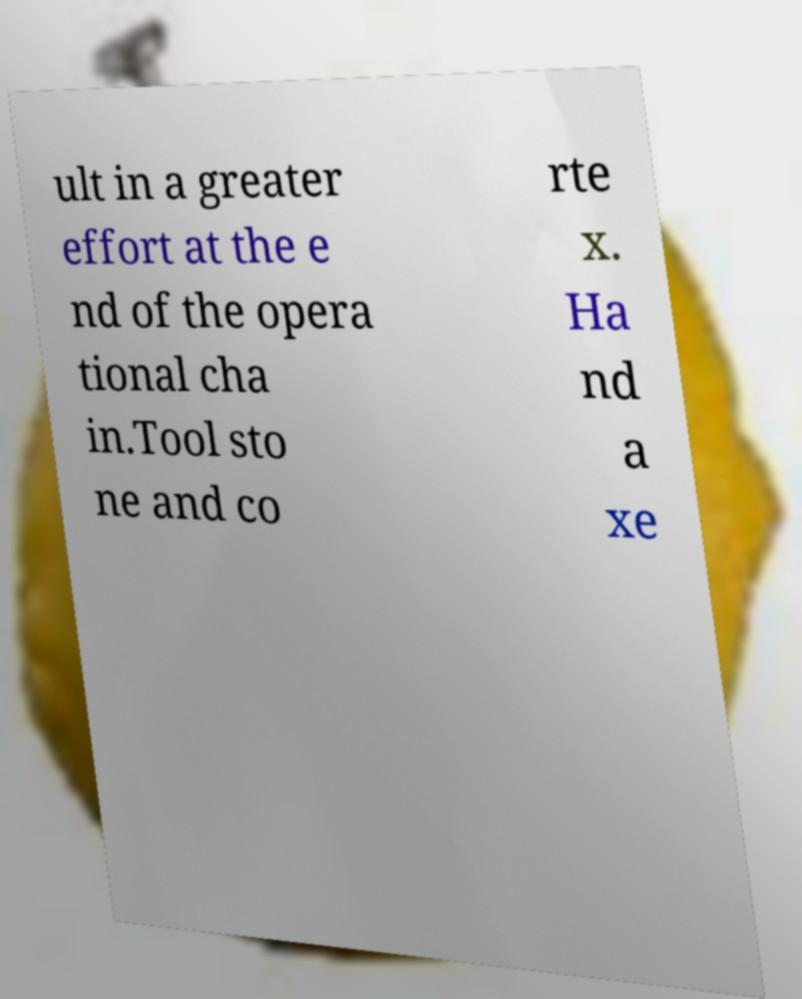Could you assist in decoding the text presented in this image and type it out clearly? ult in a greater effort at the e nd of the opera tional cha in.Tool sto ne and co rte x. Ha nd a xe 